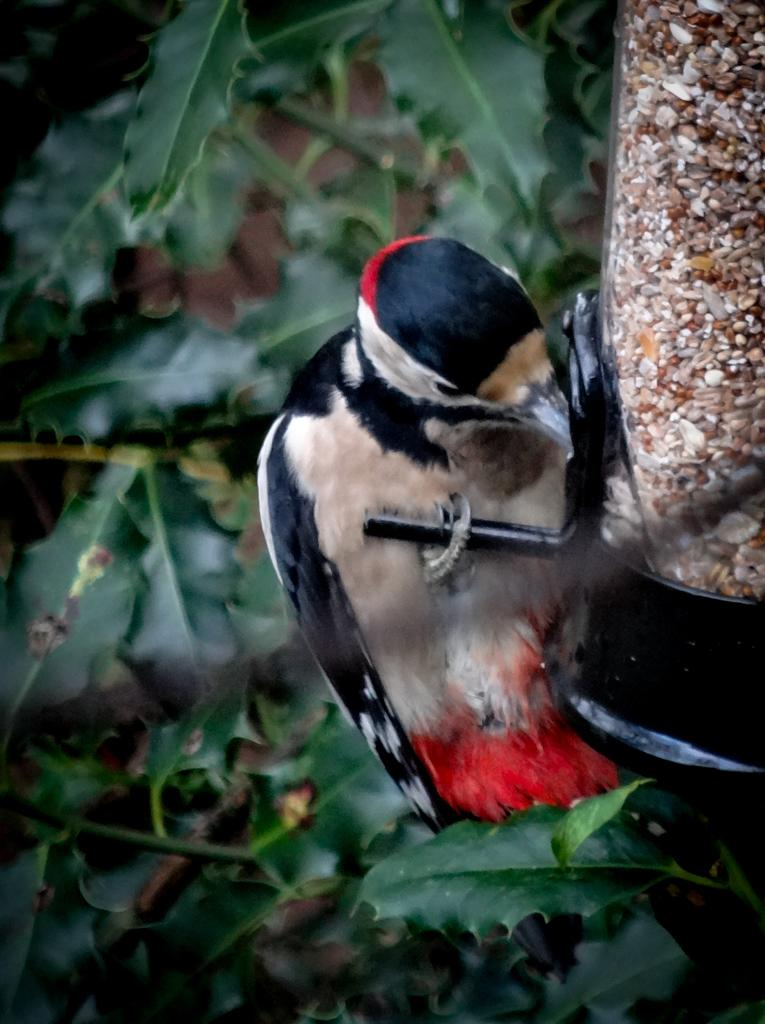What type of animal is in the image? There is a bird in the image. What colors can be seen on the bird? The bird has red, cream, and black colors. What can be seen in the background of the image? The background of the image contains green leaves. How does the bird smash the line in the image? There is no line present in the image, and the bird is not shown smashing anything. 